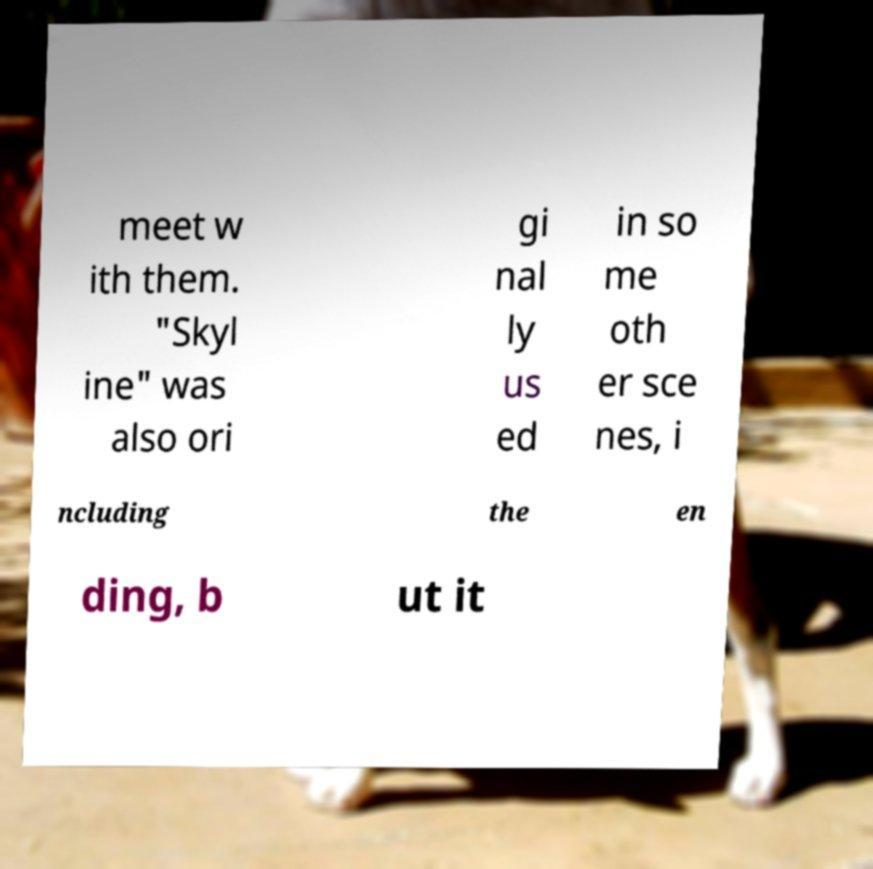Please read and relay the text visible in this image. What does it say? meet w ith them. "Skyl ine" was also ori gi nal ly us ed in so me oth er sce nes, i ncluding the en ding, b ut it 